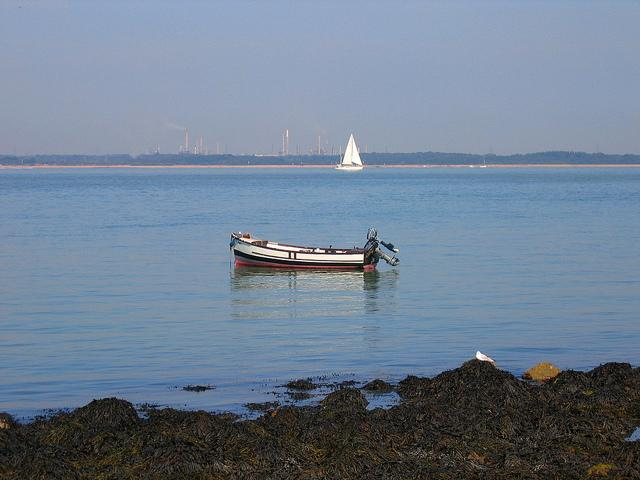What is in the background? sailboat 